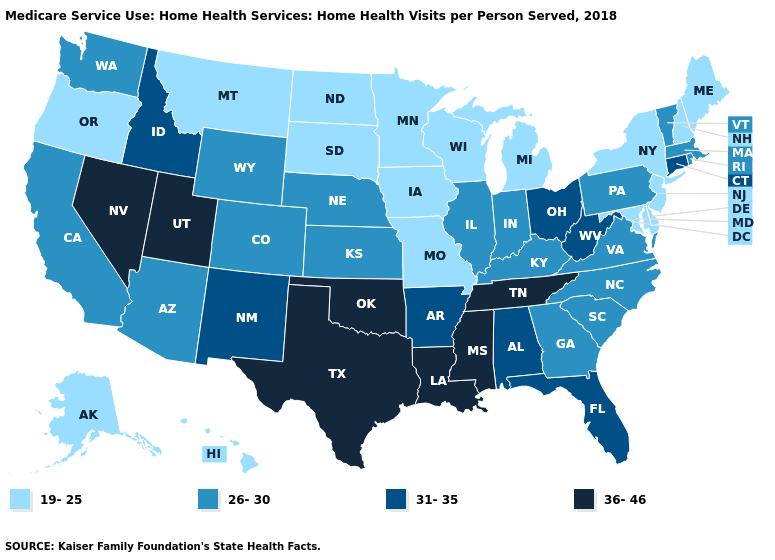What is the lowest value in the USA?
Short answer required. 19-25. What is the lowest value in the West?
Be succinct. 19-25. What is the value of Idaho?
Give a very brief answer. 31-35. Is the legend a continuous bar?
Concise answer only. No. Does New Hampshire have the highest value in the Northeast?
Be succinct. No. Name the states that have a value in the range 36-46?
Quick response, please. Louisiana, Mississippi, Nevada, Oklahoma, Tennessee, Texas, Utah. Name the states that have a value in the range 19-25?
Give a very brief answer. Alaska, Delaware, Hawaii, Iowa, Maine, Maryland, Michigan, Minnesota, Missouri, Montana, New Hampshire, New Jersey, New York, North Dakota, Oregon, South Dakota, Wisconsin. What is the value of New York?
Quick response, please. 19-25. Does Montana have a lower value than Virginia?
Be succinct. Yes. What is the highest value in the MidWest ?
Concise answer only. 31-35. Among the states that border Wyoming , which have the highest value?
Be succinct. Utah. Does Nebraska have the highest value in the MidWest?
Be succinct. No. Among the states that border Oklahoma , does Missouri have the lowest value?
Concise answer only. Yes. Name the states that have a value in the range 36-46?
Write a very short answer. Louisiana, Mississippi, Nevada, Oklahoma, Tennessee, Texas, Utah. Name the states that have a value in the range 31-35?
Be succinct. Alabama, Arkansas, Connecticut, Florida, Idaho, New Mexico, Ohio, West Virginia. 